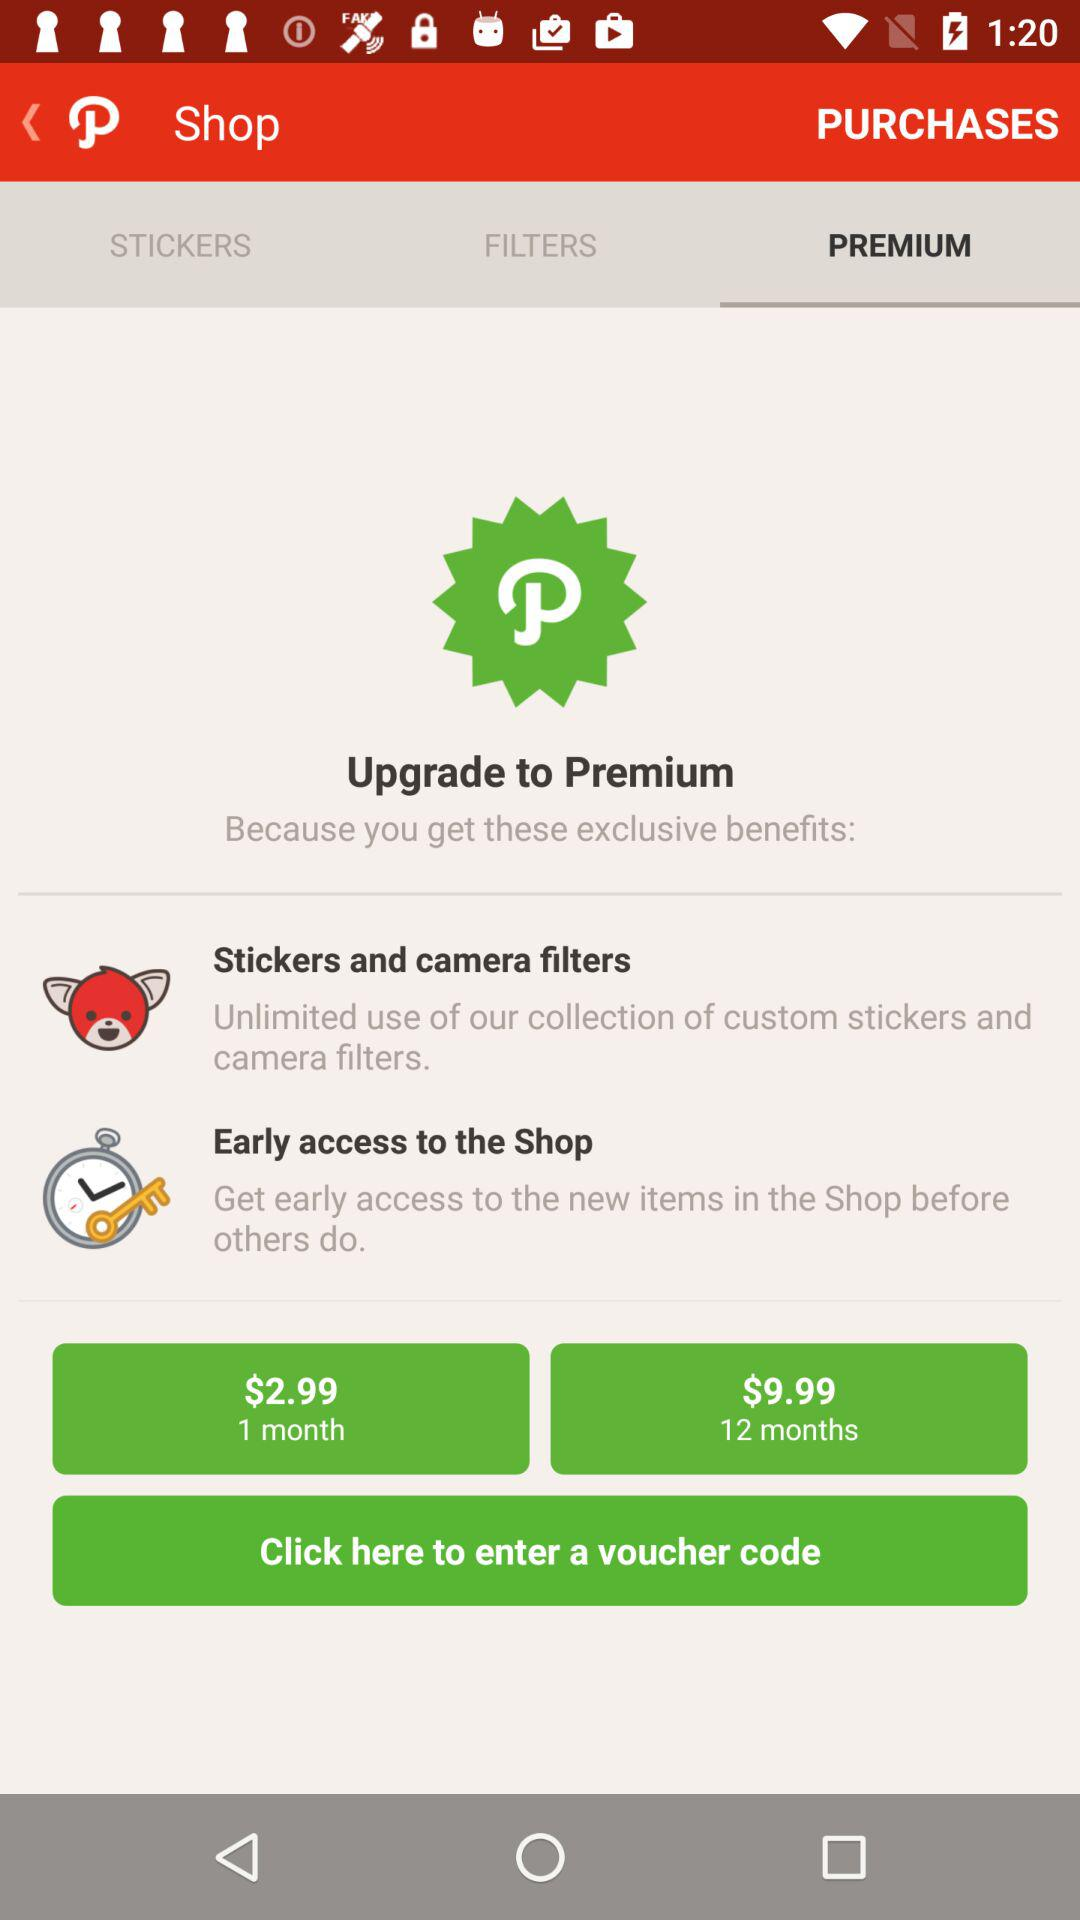What is the currency for the prices? The currency for the prices is the dollar. 